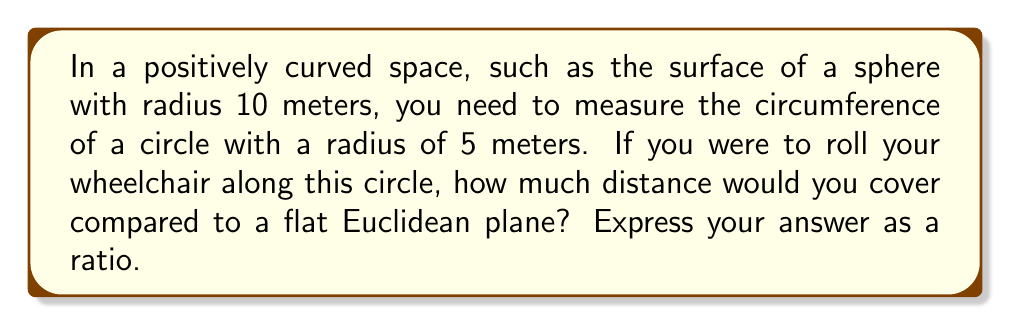Teach me how to tackle this problem. Let's approach this step-by-step:

1) In a positively curved space like a sphere, the circumference of a circle is smaller than it would be on a flat plane.

2) The formula for the circumference of a circle on a sphere with radius $R$ is:

   $$C = 2\pi R \sin(\frac{r}{R})$$

   Where $r$ is the radius of the circle on the surface.

3) In our case, $R = 10$ meters (radius of the sphere) and $r = 5$ meters (radius of the circle).

4) Let's calculate the circumference on the sphere:

   $$C_{sphere} = 2\pi(10)\sin(\frac{5}{10}) = 20\pi\sin(0.5) \approx 30.27 \text{ meters}$$

5) Now, let's calculate what the circumference would be on a flat plane:

   $$C_{flat} = 2\pi r = 2\pi(5) = 10\pi \approx 31.42 \text{ meters}$$

6) The ratio of the curved space circumference to the flat space circumference is:

   $$\frac{C_{sphere}}{C_{flat}} = \frac{20\pi\sin(0.5)}{10\pi} = 2\sin(0.5) \approx 0.9635$$

[asy]
import geometry;

size(200);
real R = 10;
real r = 5;
real theta = r/R;

pair O = (0,0);
draw(circle(O, R), blue);
pair P = R*dir(90-theta);
draw(O--P, dashed);
draw(arc(O, P, theta*2), red);
label("R", (O--P)/2, W);
label("r", O--R*dir(90), E);
label("sphere", (5,-11));
[/asy]
Answer: $2\sin(0.5) \approx 0.9635$ 